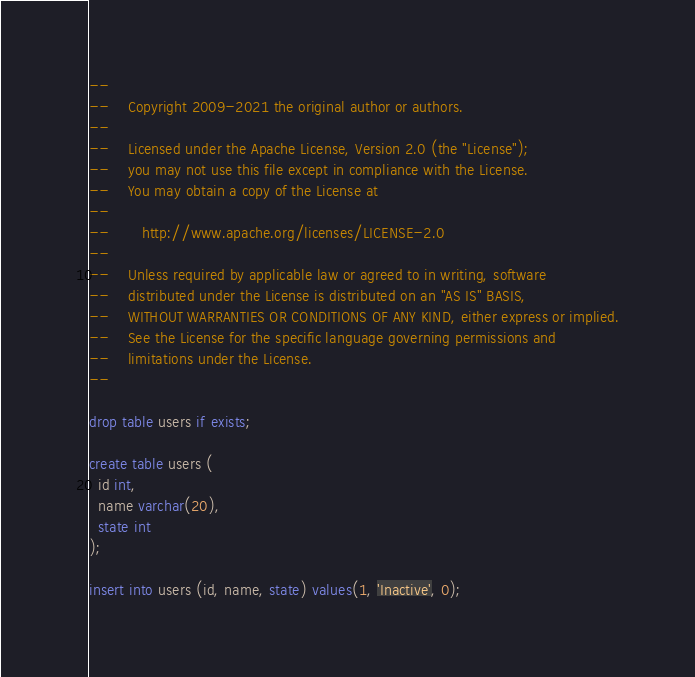Convert code to text. <code><loc_0><loc_0><loc_500><loc_500><_SQL_>--
--    Copyright 2009-2021 the original author or authors.
--
--    Licensed under the Apache License, Version 2.0 (the "License");
--    you may not use this file except in compliance with the License.
--    You may obtain a copy of the License at
--
--       http://www.apache.org/licenses/LICENSE-2.0
--
--    Unless required by applicable law or agreed to in writing, software
--    distributed under the License is distributed on an "AS IS" BASIS,
--    WITHOUT WARRANTIES OR CONDITIONS OF ANY KIND, either express or implied.
--    See the License for the specific language governing permissions and
--    limitations under the License.
--

drop table users if exists;

create table users (
  id int,
  name varchar(20),
  state int
);

insert into users (id, name, state) values(1, 'Inactive', 0);
</code> 